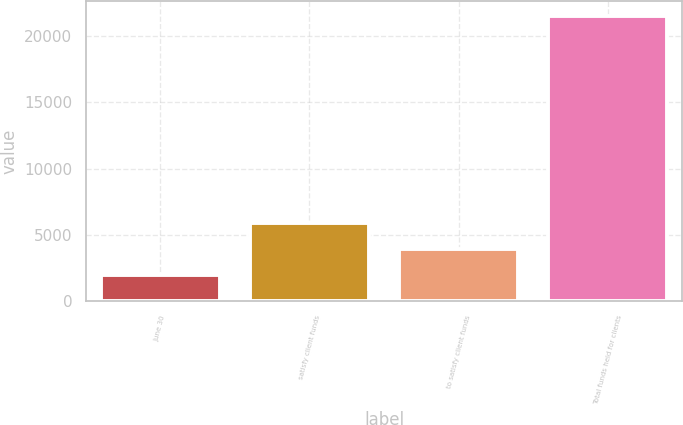<chart> <loc_0><loc_0><loc_500><loc_500><bar_chart><fcel>June 30<fcel>satisfy client funds<fcel>to satisfy client funds<fcel>Total funds held for clients<nl><fcel>2012<fcel>5917.42<fcel>3964.71<fcel>21539.1<nl></chart> 